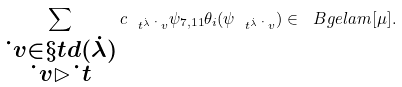<formula> <loc_0><loc_0><loc_500><loc_500>\sum _ { \substack { \dot { \ } v \in \S t d ( \dot { \lambda } ) \\ \dot { \ } v \rhd \dot { \ } t } } c _ { \ t ^ { \dot { \lambda } } \dot { \ } v } \psi _ { 7 , 1 1 } \theta _ { i } ( \psi _ { \ t ^ { \dot { \lambda } } \dot { \ } v } ) \in \ B g e l a m [ \mu ] .</formula> 